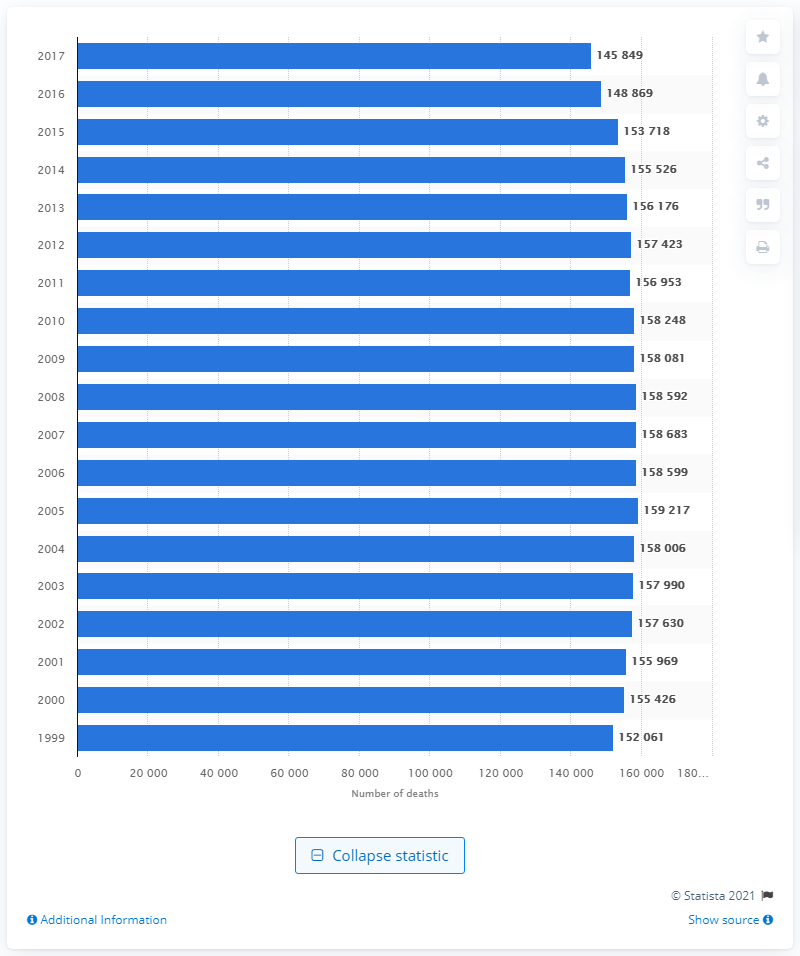Can we deduce any seasonal trends in the lung and bronchus cancer deaths from this graph? The graph doesn't provide information on seasonal trends as it aggregates annual data. For seasonal trends, a more detailed dataset that includes monthly or quarterly information would be required. 